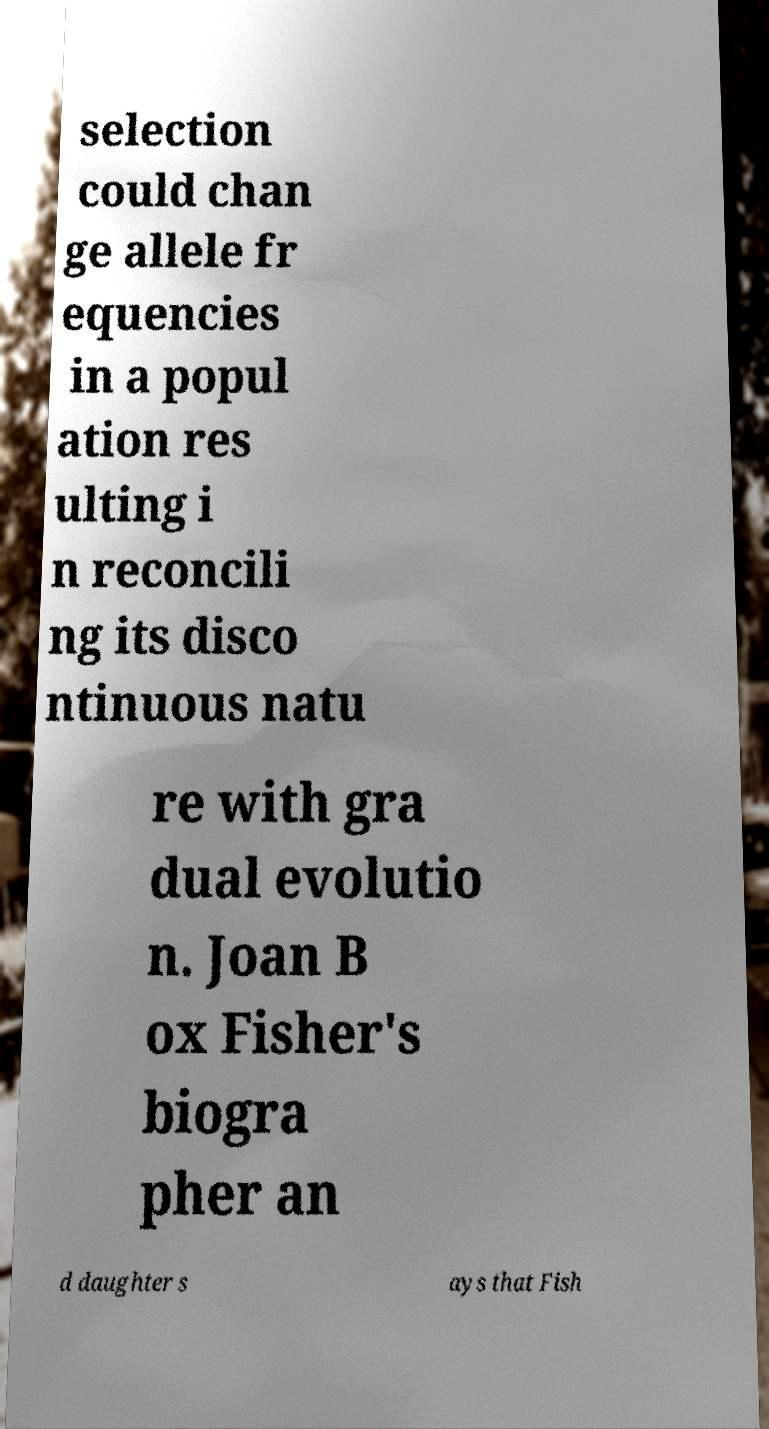Please read and relay the text visible in this image. What does it say? selection could chan ge allele fr equencies in a popul ation res ulting i n reconcili ng its disco ntinuous natu re with gra dual evolutio n. Joan B ox Fisher's biogra pher an d daughter s ays that Fish 